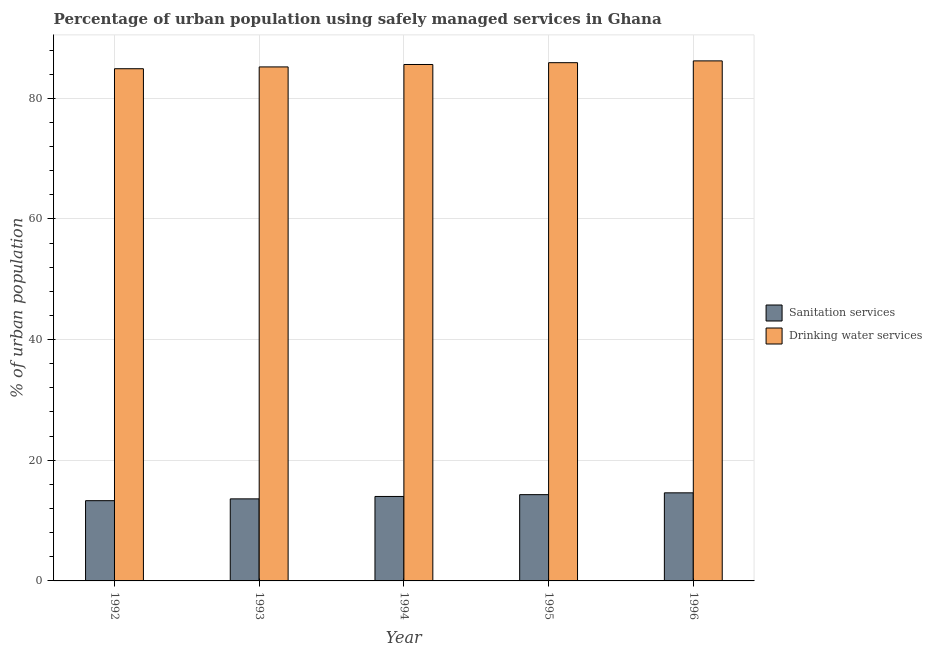Are the number of bars on each tick of the X-axis equal?
Offer a terse response. Yes. What is the percentage of urban population who used drinking water services in 1996?
Keep it short and to the point. 86.2. Across all years, what is the maximum percentage of urban population who used sanitation services?
Ensure brevity in your answer.  14.6. In which year was the percentage of urban population who used drinking water services minimum?
Ensure brevity in your answer.  1992. What is the total percentage of urban population who used drinking water services in the graph?
Provide a succinct answer. 427.8. What is the difference between the percentage of urban population who used sanitation services in 1992 and that in 1994?
Provide a short and direct response. -0.7. What is the difference between the percentage of urban population who used drinking water services in 1996 and the percentage of urban population who used sanitation services in 1995?
Provide a short and direct response. 0.3. What is the average percentage of urban population who used drinking water services per year?
Make the answer very short. 85.56. What is the ratio of the percentage of urban population who used sanitation services in 1992 to that in 1993?
Ensure brevity in your answer.  0.98. What is the difference between the highest and the second highest percentage of urban population who used sanitation services?
Make the answer very short. 0.3. What is the difference between the highest and the lowest percentage of urban population who used sanitation services?
Your answer should be very brief. 1.3. What does the 2nd bar from the left in 1993 represents?
Make the answer very short. Drinking water services. What does the 1st bar from the right in 1996 represents?
Give a very brief answer. Drinking water services. How many bars are there?
Give a very brief answer. 10. What is the difference between two consecutive major ticks on the Y-axis?
Give a very brief answer. 20. Are the values on the major ticks of Y-axis written in scientific E-notation?
Make the answer very short. No. Does the graph contain any zero values?
Give a very brief answer. No. Does the graph contain grids?
Your answer should be compact. Yes. How many legend labels are there?
Provide a short and direct response. 2. What is the title of the graph?
Your answer should be very brief. Percentage of urban population using safely managed services in Ghana. What is the label or title of the Y-axis?
Ensure brevity in your answer.  % of urban population. What is the % of urban population in Drinking water services in 1992?
Your response must be concise. 84.9. What is the % of urban population of Drinking water services in 1993?
Offer a terse response. 85.2. What is the % of urban population in Sanitation services in 1994?
Your answer should be compact. 14. What is the % of urban population in Drinking water services in 1994?
Your response must be concise. 85.6. What is the % of urban population of Drinking water services in 1995?
Your response must be concise. 85.9. What is the % of urban population in Drinking water services in 1996?
Provide a succinct answer. 86.2. Across all years, what is the maximum % of urban population in Sanitation services?
Make the answer very short. 14.6. Across all years, what is the maximum % of urban population of Drinking water services?
Ensure brevity in your answer.  86.2. Across all years, what is the minimum % of urban population of Drinking water services?
Keep it short and to the point. 84.9. What is the total % of urban population of Sanitation services in the graph?
Provide a short and direct response. 69.8. What is the total % of urban population of Drinking water services in the graph?
Offer a very short reply. 427.8. What is the difference between the % of urban population in Drinking water services in 1992 and that in 1993?
Make the answer very short. -0.3. What is the difference between the % of urban population of Sanitation services in 1992 and that in 1994?
Your answer should be very brief. -0.7. What is the difference between the % of urban population in Sanitation services in 1992 and that in 1995?
Offer a very short reply. -1. What is the difference between the % of urban population in Drinking water services in 1992 and that in 1995?
Provide a short and direct response. -1. What is the difference between the % of urban population of Sanitation services in 1992 and that in 1996?
Provide a succinct answer. -1.3. What is the difference between the % of urban population of Drinking water services in 1992 and that in 1996?
Your response must be concise. -1.3. What is the difference between the % of urban population of Sanitation services in 1993 and that in 1994?
Ensure brevity in your answer.  -0.4. What is the difference between the % of urban population of Drinking water services in 1993 and that in 1996?
Keep it short and to the point. -1. What is the difference between the % of urban population of Sanitation services in 1995 and that in 1996?
Ensure brevity in your answer.  -0.3. What is the difference between the % of urban population in Sanitation services in 1992 and the % of urban population in Drinking water services in 1993?
Provide a succinct answer. -71.9. What is the difference between the % of urban population in Sanitation services in 1992 and the % of urban population in Drinking water services in 1994?
Your answer should be very brief. -72.3. What is the difference between the % of urban population in Sanitation services in 1992 and the % of urban population in Drinking water services in 1995?
Provide a succinct answer. -72.6. What is the difference between the % of urban population in Sanitation services in 1992 and the % of urban population in Drinking water services in 1996?
Your answer should be very brief. -72.9. What is the difference between the % of urban population in Sanitation services in 1993 and the % of urban population in Drinking water services in 1994?
Provide a succinct answer. -72. What is the difference between the % of urban population of Sanitation services in 1993 and the % of urban population of Drinking water services in 1995?
Provide a succinct answer. -72.3. What is the difference between the % of urban population in Sanitation services in 1993 and the % of urban population in Drinking water services in 1996?
Offer a very short reply. -72.6. What is the difference between the % of urban population in Sanitation services in 1994 and the % of urban population in Drinking water services in 1995?
Provide a short and direct response. -71.9. What is the difference between the % of urban population in Sanitation services in 1994 and the % of urban population in Drinking water services in 1996?
Ensure brevity in your answer.  -72.2. What is the difference between the % of urban population in Sanitation services in 1995 and the % of urban population in Drinking water services in 1996?
Give a very brief answer. -71.9. What is the average % of urban population of Sanitation services per year?
Keep it short and to the point. 13.96. What is the average % of urban population in Drinking water services per year?
Offer a very short reply. 85.56. In the year 1992, what is the difference between the % of urban population in Sanitation services and % of urban population in Drinking water services?
Provide a succinct answer. -71.6. In the year 1993, what is the difference between the % of urban population of Sanitation services and % of urban population of Drinking water services?
Your answer should be very brief. -71.6. In the year 1994, what is the difference between the % of urban population of Sanitation services and % of urban population of Drinking water services?
Your response must be concise. -71.6. In the year 1995, what is the difference between the % of urban population in Sanitation services and % of urban population in Drinking water services?
Provide a succinct answer. -71.6. In the year 1996, what is the difference between the % of urban population of Sanitation services and % of urban population of Drinking water services?
Your answer should be very brief. -71.6. What is the ratio of the % of urban population of Sanitation services in 1992 to that in 1993?
Make the answer very short. 0.98. What is the ratio of the % of urban population in Drinking water services in 1992 to that in 1993?
Give a very brief answer. 1. What is the ratio of the % of urban population of Sanitation services in 1992 to that in 1995?
Make the answer very short. 0.93. What is the ratio of the % of urban population of Drinking water services in 1992 to that in 1995?
Make the answer very short. 0.99. What is the ratio of the % of urban population of Sanitation services in 1992 to that in 1996?
Give a very brief answer. 0.91. What is the ratio of the % of urban population in Drinking water services in 1992 to that in 1996?
Make the answer very short. 0.98. What is the ratio of the % of urban population of Sanitation services in 1993 to that in 1994?
Ensure brevity in your answer.  0.97. What is the ratio of the % of urban population in Sanitation services in 1993 to that in 1995?
Your answer should be very brief. 0.95. What is the ratio of the % of urban population of Drinking water services in 1993 to that in 1995?
Your response must be concise. 0.99. What is the ratio of the % of urban population of Sanitation services in 1993 to that in 1996?
Offer a terse response. 0.93. What is the ratio of the % of urban population in Drinking water services in 1993 to that in 1996?
Ensure brevity in your answer.  0.99. What is the ratio of the % of urban population in Drinking water services in 1994 to that in 1995?
Keep it short and to the point. 1. What is the ratio of the % of urban population in Sanitation services in 1994 to that in 1996?
Your answer should be very brief. 0.96. What is the ratio of the % of urban population in Sanitation services in 1995 to that in 1996?
Your answer should be compact. 0.98. What is the ratio of the % of urban population of Drinking water services in 1995 to that in 1996?
Provide a succinct answer. 1. What is the difference between the highest and the second highest % of urban population of Sanitation services?
Your answer should be very brief. 0.3. What is the difference between the highest and the lowest % of urban population of Drinking water services?
Your response must be concise. 1.3. 